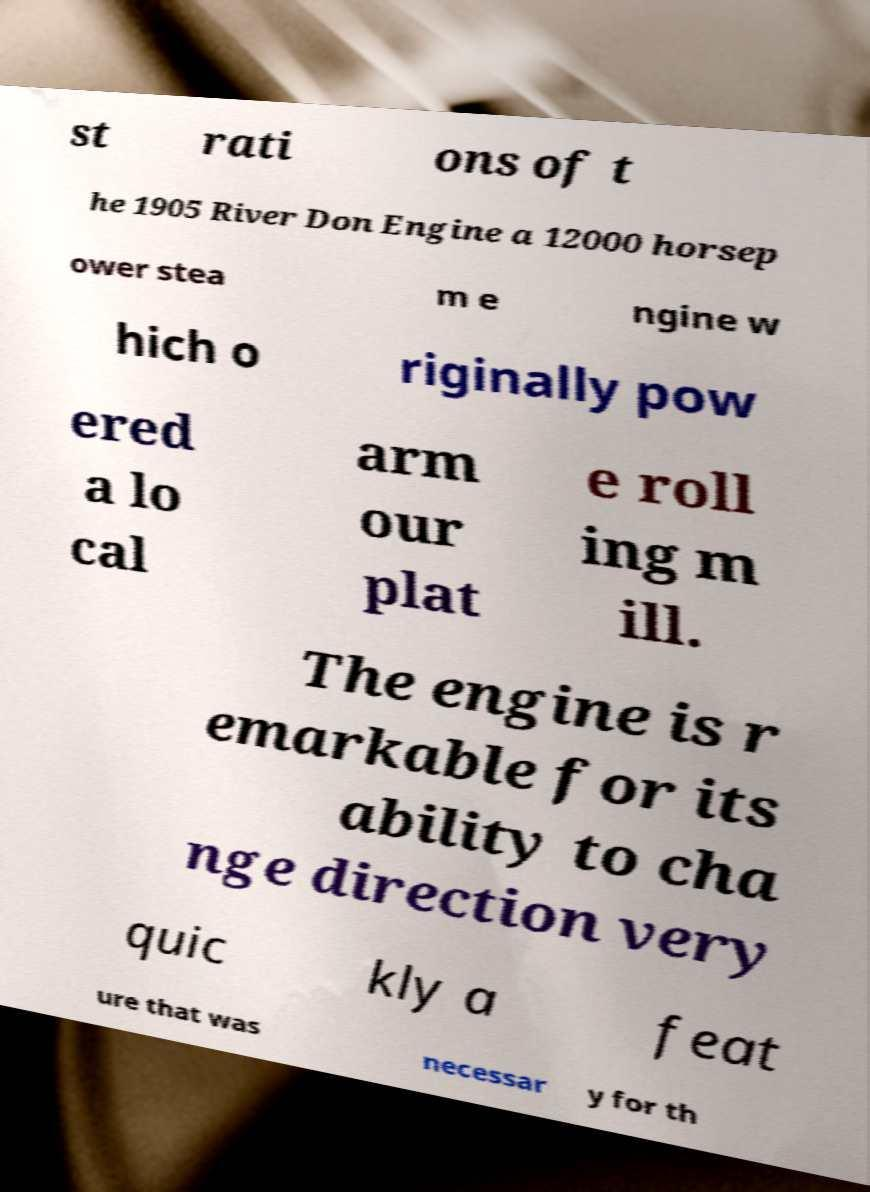Could you extract and type out the text from this image? st rati ons of t he 1905 River Don Engine a 12000 horsep ower stea m e ngine w hich o riginally pow ered a lo cal arm our plat e roll ing m ill. The engine is r emarkable for its ability to cha nge direction very quic kly a feat ure that was necessar y for th 